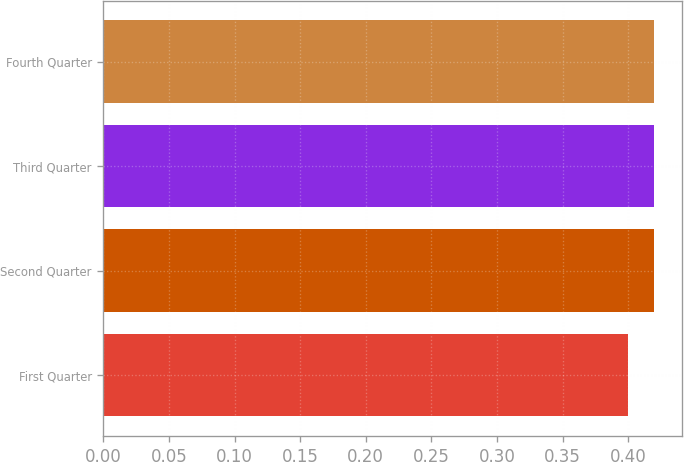<chart> <loc_0><loc_0><loc_500><loc_500><bar_chart><fcel>First Quarter<fcel>Second Quarter<fcel>Third Quarter<fcel>Fourth Quarter<nl><fcel>0.4<fcel>0.42<fcel>0.42<fcel>0.42<nl></chart> 